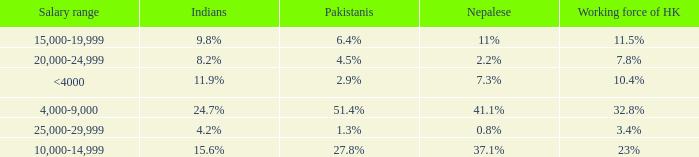If the working force of HK is 10.4%, what is the salary range? <4000. 